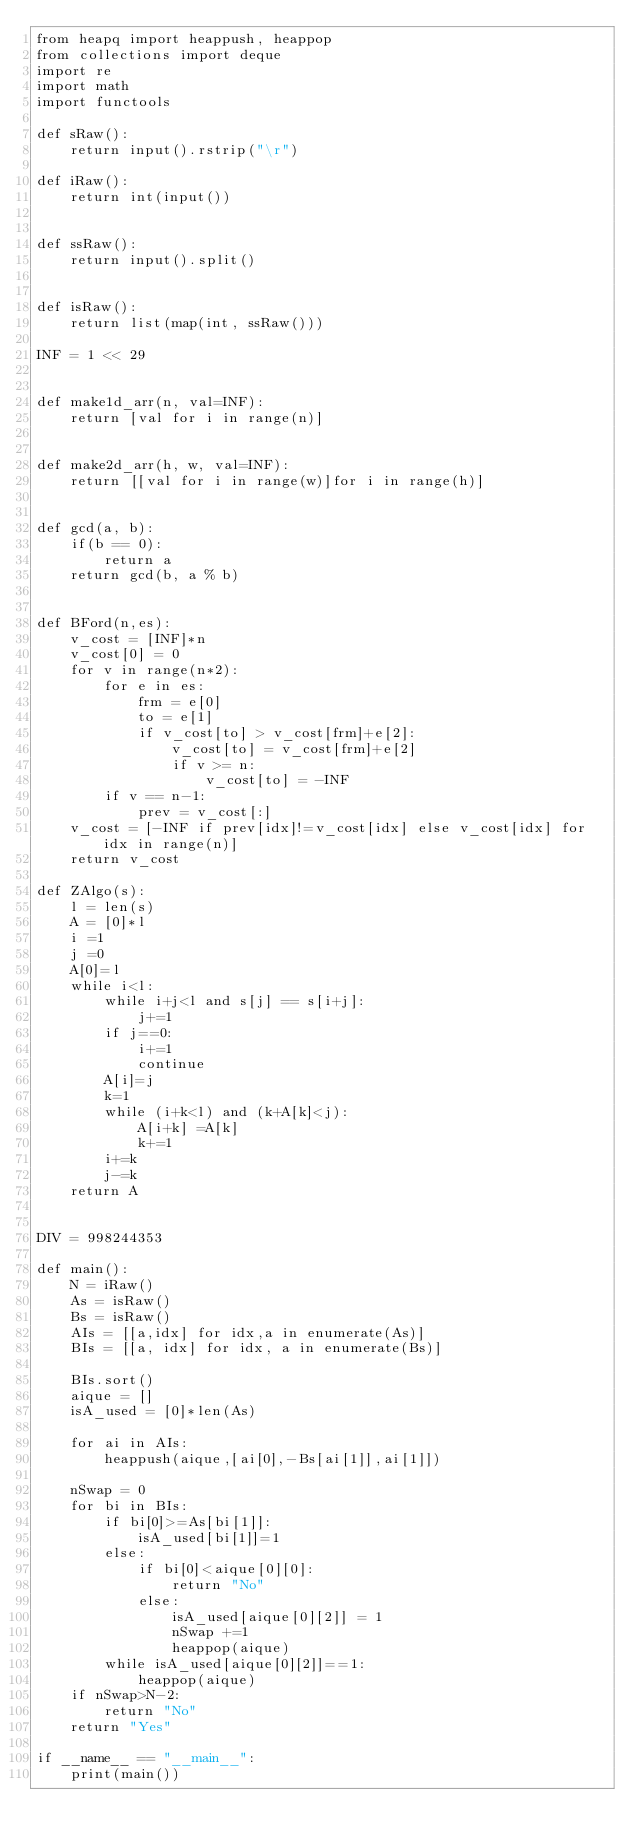<code> <loc_0><loc_0><loc_500><loc_500><_Python_>from heapq import heappush, heappop
from collections import deque
import re
import math
import functools

def sRaw():
    return input().rstrip("\r")

def iRaw():
    return int(input())


def ssRaw():
    return input().split()


def isRaw():
    return list(map(int, ssRaw()))

INF = 1 << 29


def make1d_arr(n, val=INF):
    return [val for i in range(n)]


def make2d_arr(h, w, val=INF):
    return [[val for i in range(w)]for i in range(h)]


def gcd(a, b):
    if(b == 0):
        return a
    return gcd(b, a % b)


def BFord(n,es):
    v_cost = [INF]*n
    v_cost[0] = 0
    for v in range(n*2):
        for e in es:
            frm = e[0]
            to = e[1]
            if v_cost[to] > v_cost[frm]+e[2]:
                v_cost[to] = v_cost[frm]+e[2]
                if v >= n:
                    v_cost[to] = -INF
        if v == n-1:
            prev = v_cost[:]
    v_cost = [-INF if prev[idx]!=v_cost[idx] else v_cost[idx] for idx in range(n)]
    return v_cost
    
def ZAlgo(s):
    l = len(s)
    A = [0]*l
    i =1
    j =0
    A[0]=l
    while i<l:
        while i+j<l and s[j] == s[i+j]:
            j+=1
        if j==0:
            i+=1
            continue
        A[i]=j
        k=1
        while (i+k<l) and (k+A[k]<j):
            A[i+k] =A[k]
            k+=1
        i+=k
        j-=k
    return A


DIV = 998244353

def main():
    N = iRaw()
    As = isRaw()
    Bs = isRaw()
    AIs = [[a,idx] for idx,a in enumerate(As)]
    BIs = [[a, idx] for idx, a in enumerate(Bs)]
    
    BIs.sort()
    aique = []
    isA_used = [0]*len(As) 
    
    for ai in AIs:
        heappush(aique,[ai[0],-Bs[ai[1]],ai[1]])
    
    nSwap = 0
    for bi in BIs:
        if bi[0]>=As[bi[1]]:
            isA_used[bi[1]]=1
        else:
            if bi[0]<aique[0][0]:
                return "No"
            else:
                isA_used[aique[0][2]] = 1
                nSwap +=1
                heappop(aique)
        while isA_used[aique[0][2]]==1:
            heappop(aique)
    if nSwap>N-2:
        return "No"
    return "Yes"

if __name__ == "__main__":
    print(main())
</code> 